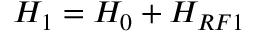Convert formula to latex. <formula><loc_0><loc_0><loc_500><loc_500>H _ { 1 } = H _ { 0 } + H _ { R F 1 }</formula> 